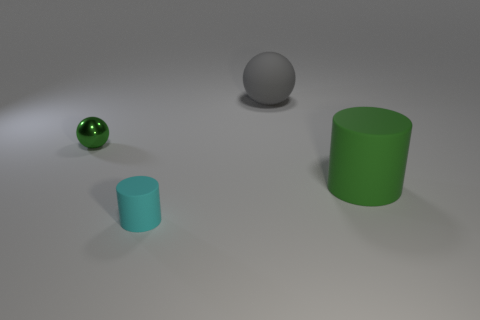Add 1 small shiny balls. How many objects exist? 5 Add 1 tiny green spheres. How many tiny green spheres exist? 2 Subtract 0 yellow spheres. How many objects are left? 4 Subtract all green things. Subtract all green balls. How many objects are left? 1 Add 4 cyan cylinders. How many cyan cylinders are left? 5 